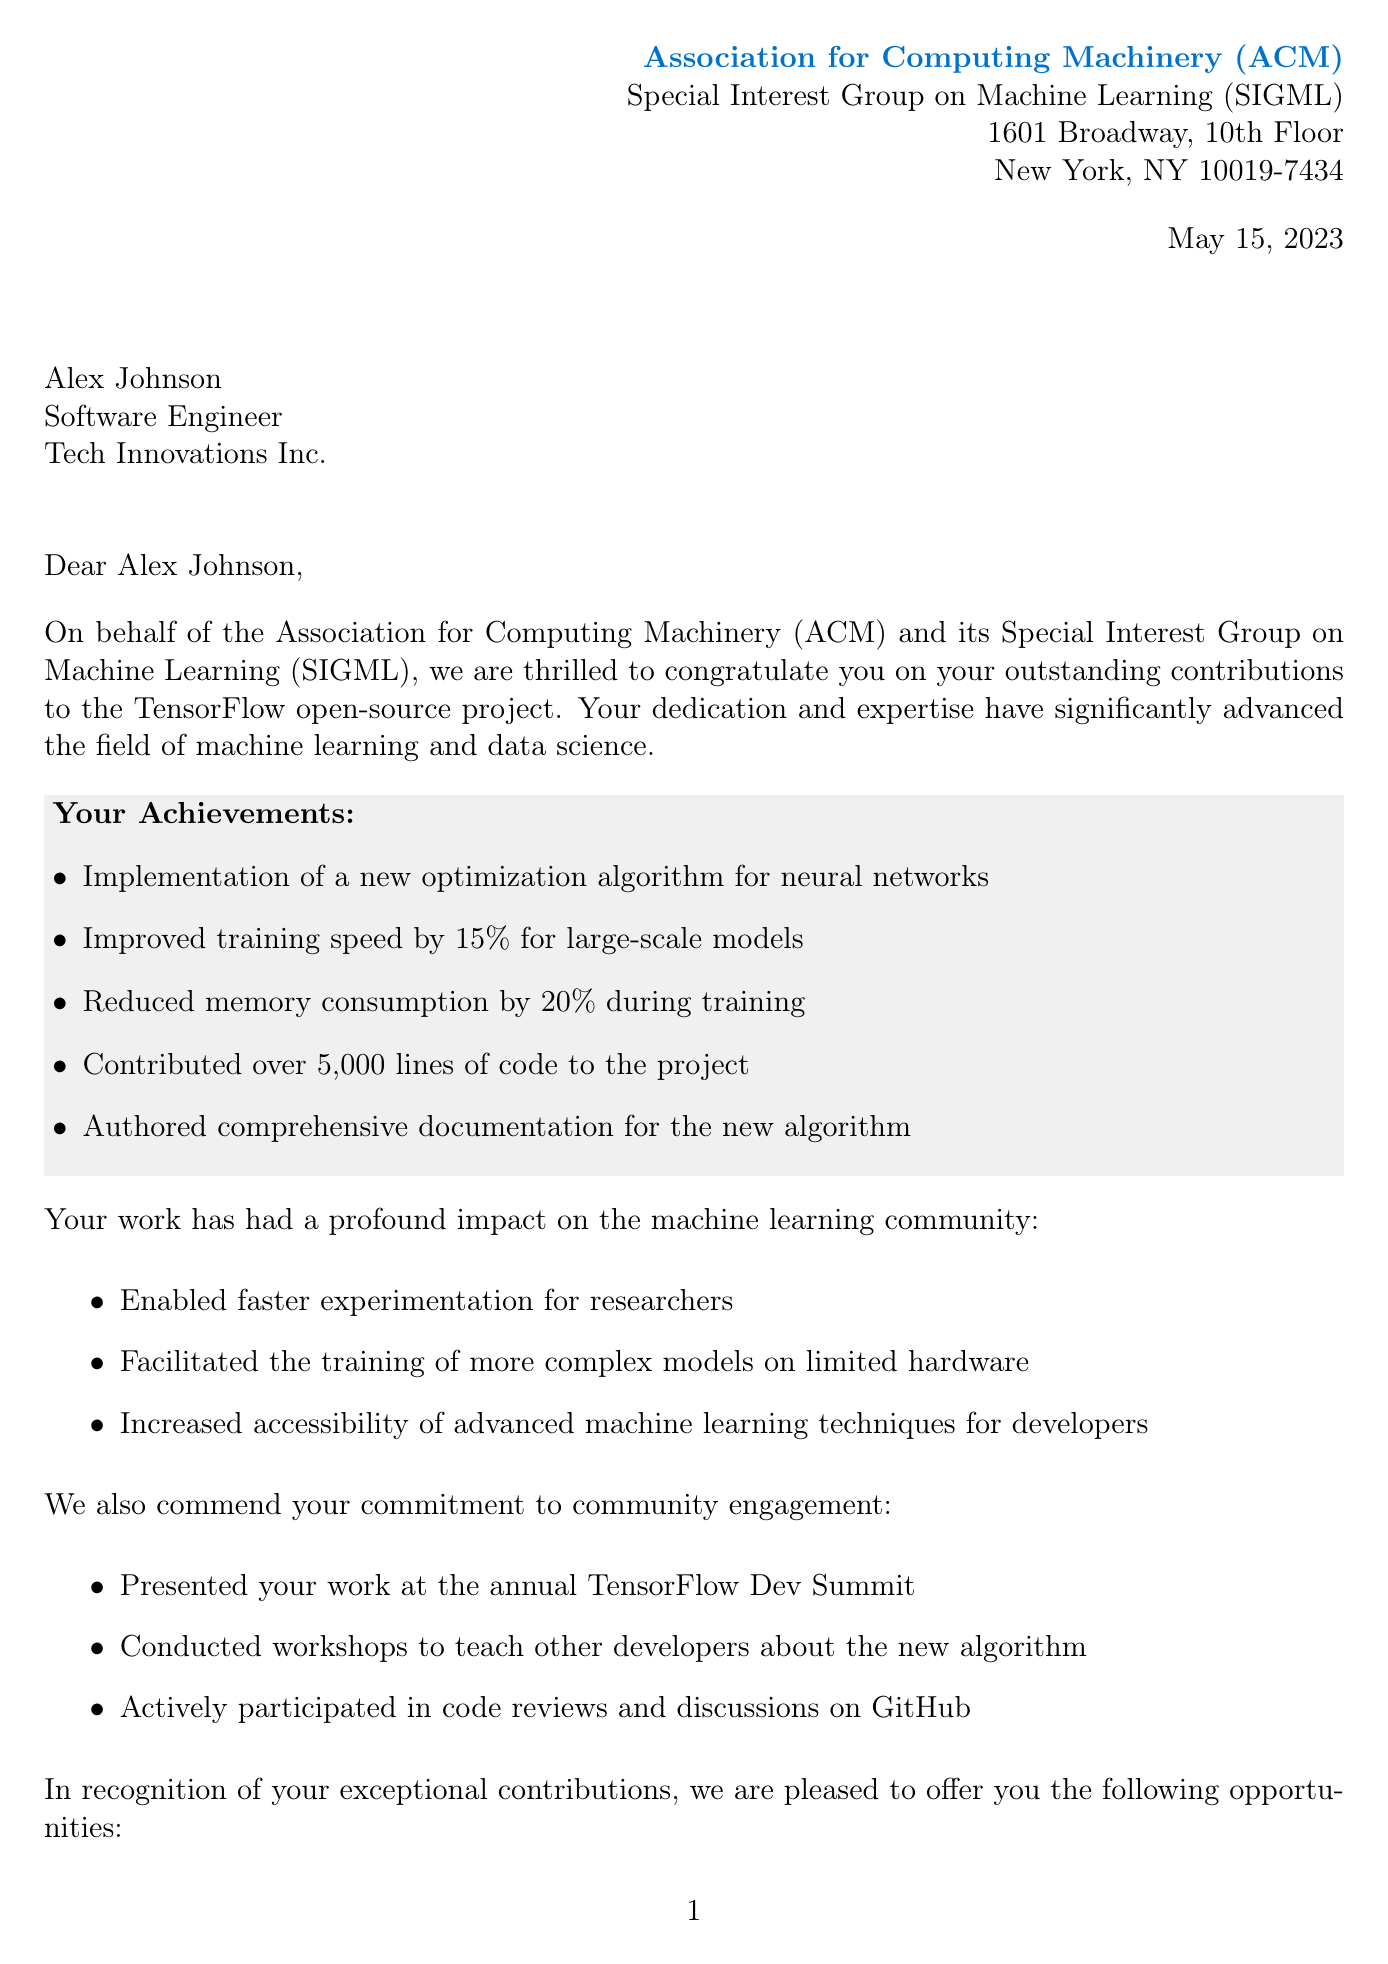What is the name of the organization? The name of the organization is explicitly mentioned in the document as the Association for Computing Machinery (ACM).
Answer: Association for Computing Machinery (ACM) What is the date of the letter? The date is clearly stated in the document as May 15, 2023.
Answer: May 15, 2023 Who is the recipient of the letter? The recipient's name is mentioned in the document as Alex Johnson.
Answer: Alex Johnson What optimization algorithm was implemented? The specific optimization algorithm is listed in the document as a new optimization algorithm for neural networks.
Answer: New optimization algorithm for neural networks How much was the training speed improved by? The document states that the training speed was improved by 15% for large-scale models.
Answer: 15% What opportunity is offered regarding the ACM SIGML conference? The letter mentions a speaking opportunity at the upcoming ACM SIGML conference.
Answer: Speaking opportunity How many lines of code were contributed to the project? The document specifies that over 5,000 lines of code were contributed to the project.
Answer: Over 5,000 lines Who signed the letter as Chair of ACM SIGML? The document lists Dr. Emily Chen as the Chair of ACM SIGML.
Answer: Dr. Emily Chen What was one activity related to community engagement mentioned? The letter highlights that the recipient conducted workshops to teach developers about the new algorithm.
Answer: Conducted workshops 